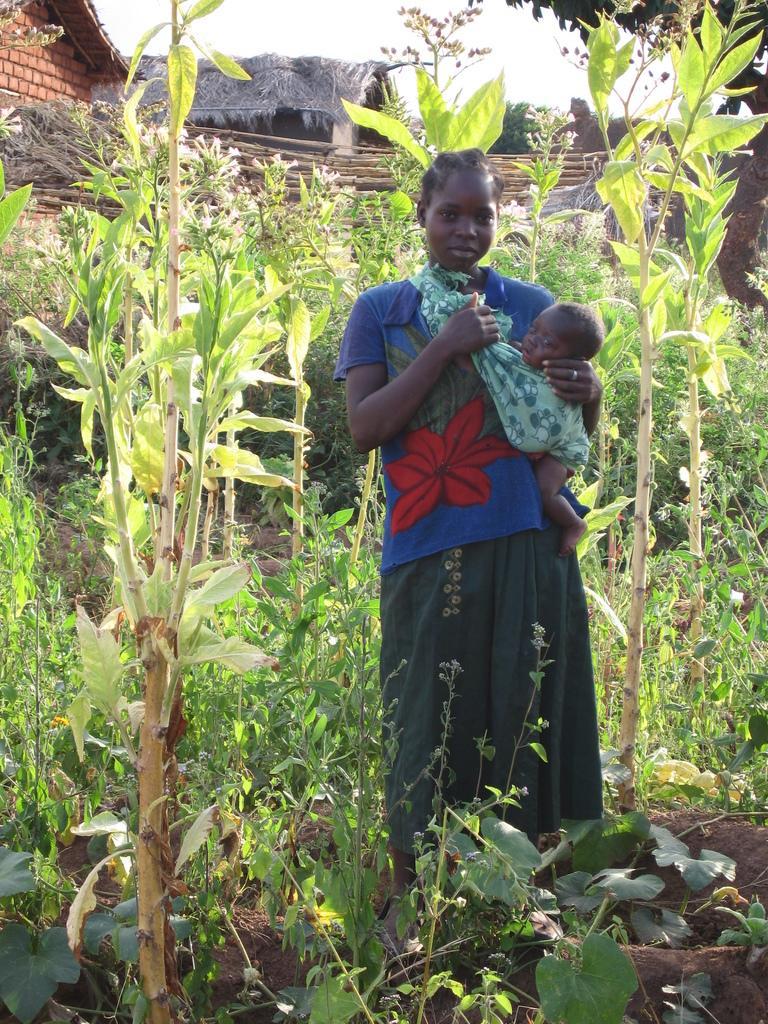How would you summarize this image in a sentence or two? In this image there is a woman holding a baby and standing in the middle of the plants and trees. In the background there is a house and the sky. 